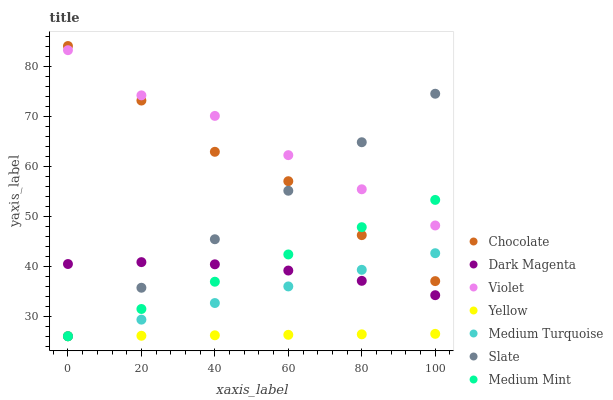Does Yellow have the minimum area under the curve?
Answer yes or no. Yes. Does Violet have the maximum area under the curve?
Answer yes or no. Yes. Does Dark Magenta have the minimum area under the curve?
Answer yes or no. No. Does Dark Magenta have the maximum area under the curve?
Answer yes or no. No. Is Medium Mint the smoothest?
Answer yes or no. Yes. Is Chocolate the roughest?
Answer yes or no. Yes. Is Dark Magenta the smoothest?
Answer yes or no. No. Is Dark Magenta the roughest?
Answer yes or no. No. Does Medium Mint have the lowest value?
Answer yes or no. Yes. Does Dark Magenta have the lowest value?
Answer yes or no. No. Does Chocolate have the highest value?
Answer yes or no. Yes. Does Dark Magenta have the highest value?
Answer yes or no. No. Is Yellow less than Violet?
Answer yes or no. Yes. Is Dark Magenta greater than Yellow?
Answer yes or no. Yes. Does Slate intersect Medium Mint?
Answer yes or no. Yes. Is Slate less than Medium Mint?
Answer yes or no. No. Is Slate greater than Medium Mint?
Answer yes or no. No. Does Yellow intersect Violet?
Answer yes or no. No. 